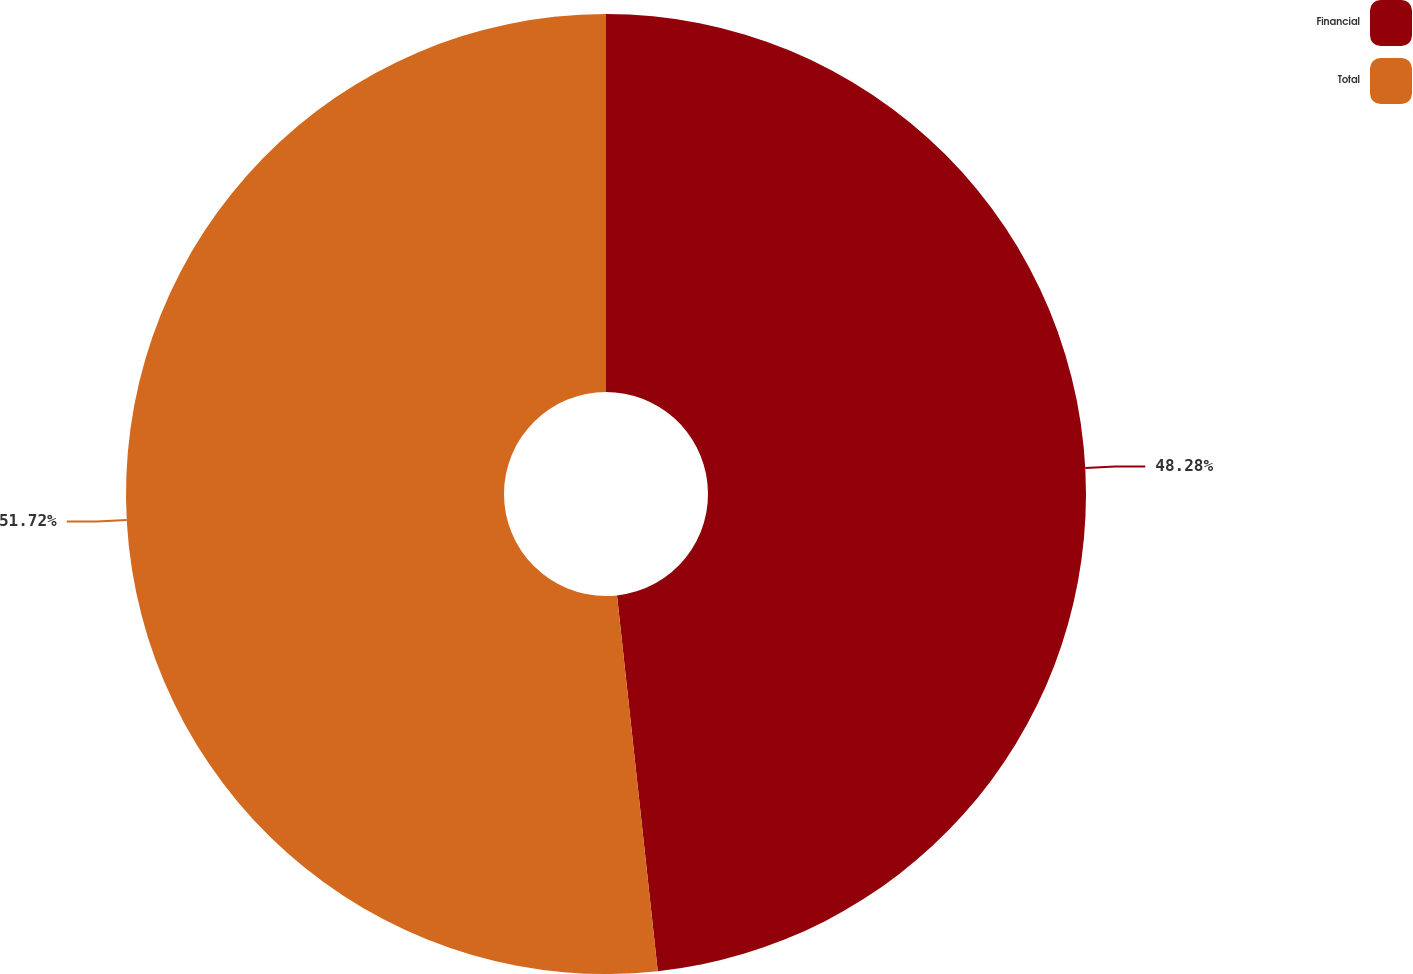Convert chart to OTSL. <chart><loc_0><loc_0><loc_500><loc_500><pie_chart><fcel>Financial<fcel>Total<nl><fcel>48.28%<fcel>51.72%<nl></chart> 